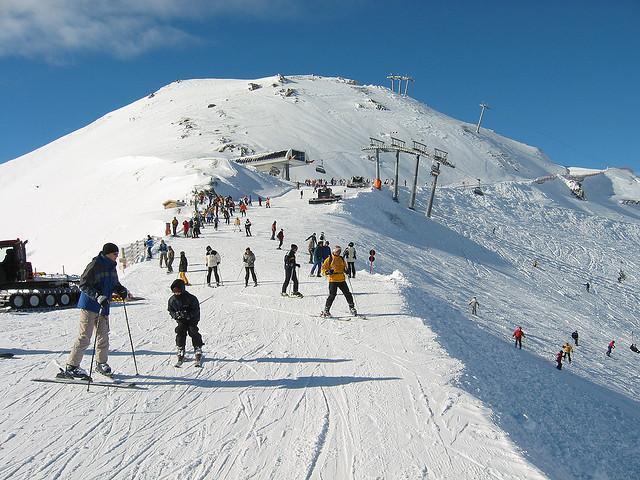What sort of skill is required at the slope in the foreground here?
From the following four choices, select the correct answer to address the question.
Options: Olympic, professional, beginner, hot dog. Beginner. 